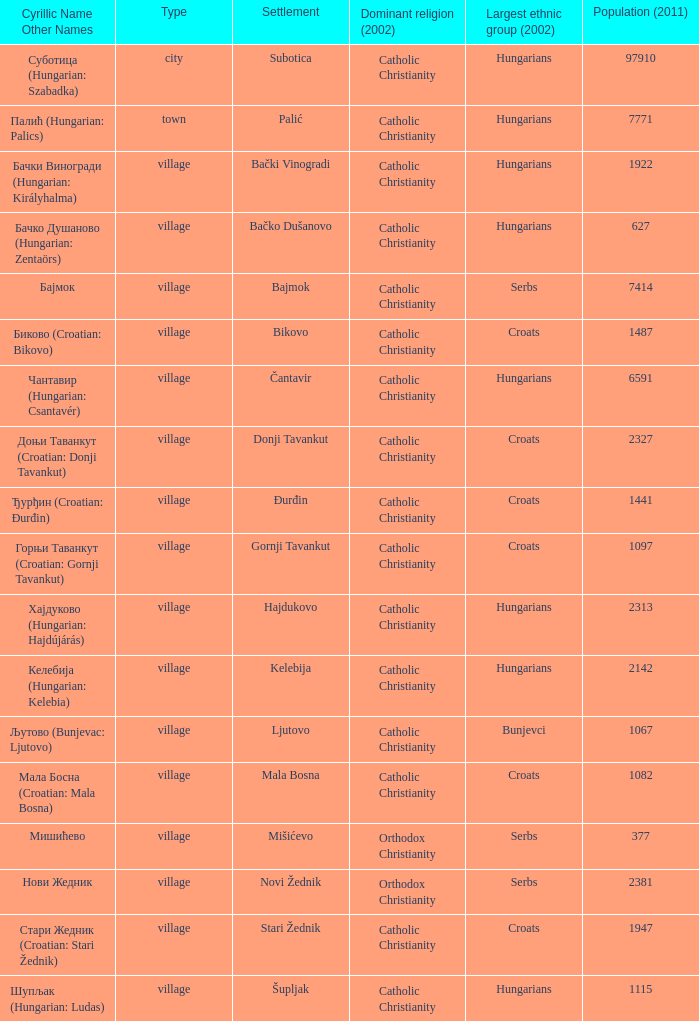What is the population in стари жедник (croatian: stari žednik)? 1947.0. 